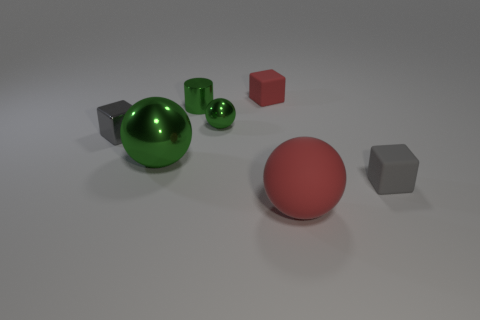How many things are either small things or big rubber spheres?
Provide a short and direct response. 6. What number of small gray metal cubes are behind the red rubber thing that is to the left of the red thing that is in front of the tiny metallic cylinder?
Keep it short and to the point. 0. There is a red object that is the same shape as the gray shiny thing; what material is it?
Make the answer very short. Rubber. There is a ball that is behind the small gray matte thing and in front of the small gray metallic thing; what is its material?
Provide a short and direct response. Metal. Is the number of green objects that are in front of the large rubber ball less than the number of tiny gray rubber objects behind the small gray rubber cube?
Ensure brevity in your answer.  No. How many other objects are the same size as the green shiny cylinder?
Offer a very short reply. 4. What shape is the tiny rubber thing behind the small gray thing to the right of the tiny green sphere on the right side of the small cylinder?
Give a very brief answer. Cube. What number of brown things are either blocks or tiny rubber things?
Give a very brief answer. 0. There is a tiny cube behind the tiny cylinder; how many small rubber cubes are on the left side of it?
Offer a very short reply. 0. Are there any other things that have the same color as the tiny metallic ball?
Your response must be concise. Yes. 